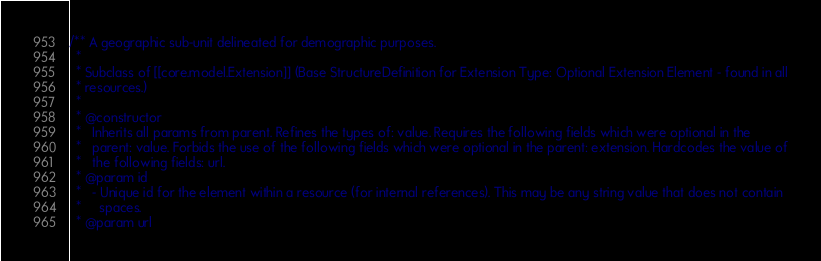<code> <loc_0><loc_0><loc_500><loc_500><_Scala_>/** A geographic sub-unit delineated for demographic purposes.
  *
  * Subclass of [[core.model.Extension]] (Base StructureDefinition for Extension Type: Optional Extension Element - found in all
  * resources.)
  *
  * @constructor
  *   Inherits all params from parent. Refines the types of: value. Requires the following fields which were optional in the
  *   parent: value. Forbids the use of the following fields which were optional in the parent: extension. Hardcodes the value of
  *   the following fields: url.
  * @param id
  *   - Unique id for the element within a resource (for internal references). This may be any string value that does not contain
  *     spaces.
  * @param url</code> 